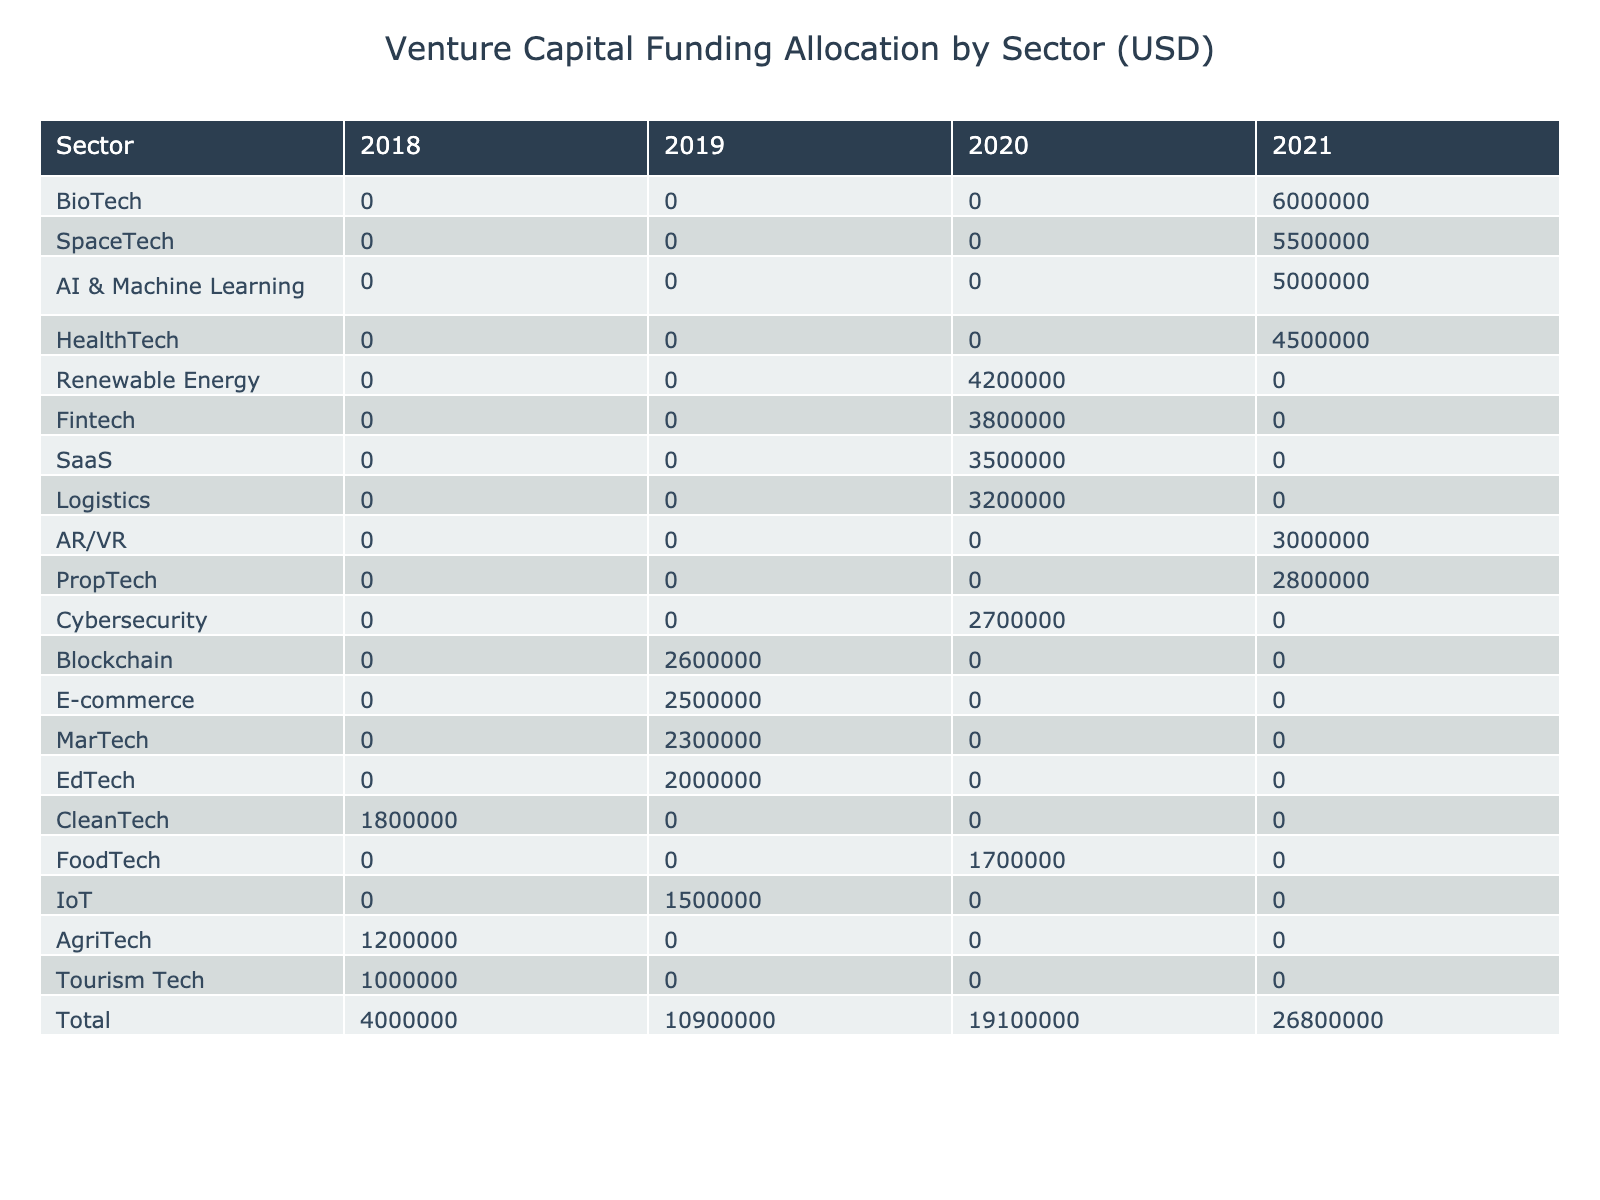What is the total investment amount for the Fintech sector? The total investment amount for the Fintech sector can be found by looking at the relevant row in the table for the years that have been reported. The amounts are 0 in 2018, 3,800,000 in 2020, and 0 in 2021, totaling 3,800,000.
Answer: 3,800,000 Which sector received the highest total funding amount? To determine which sector received the highest total funding amount, I will examine the "Total" row in the table. The highest value corresponds to the "BioTech" sector, which receives a total investment of 6,000,000.
Answer: BioTech Was there any funding for E-commerce in the year 2020? To answer this question, I need to look at the E-commerce row in the table for the year 2020. The value for E-commerce in 2020 is 0. Thus, there was no funding allocated for E-commerce in that year.
Answer: No What is the average investment amount across all years for the CleanTech sector? To find the average investment for the CleanTech sector, I first identify the amounts per year: 1,800,000 in 2018, 0 in 2019, 0 in 2020, and 0 in 2021. The total for CleanTech is 1,800,000. Then, divide this by the number of years with data (4 years), yielding an average of 1,800,000 / 4 = 450,000.
Answer: 450,000 Did any sector have more than 4 million dollars in investment in the year 2021? I will inspect the values for each sector in the year 2021. The investment amounts show that sectors such as HealthTech (4,500,000), AI & Machine Learning (5,000,000), BioTech (6,000,000), and SpaceTech (5,500,000) all exceeded 4 million. Thus, yes, multiple sectors did receive more than 4 million in that year.
Answer: Yes What is the difference between total investments in Education Tech and Agriculture Tech? The total investment for EdTech is 2,000,000, and for AgriTech, it is 1,200,000. To find the difference, subtract the AgriTech total from the EdTech total: 2,000,000 - 1,200,000 = 800,000, indicating that EdTech has 800,000 more in funding.
Answer: 800,000 Which sector had the least funding in the year 2019? For 2019, by reviewing the relevant row, I can see that the investment amounts were: 2,500,000 (E-commerce), 2,000,000 (EdTech), 1,500,000 (IoT), 3,000,000 (MarTech), and 2,600,000 (Blockchain). The sector with the least funding in 2019 was IoT, with an amount of 1,500,000.
Answer: IoT 